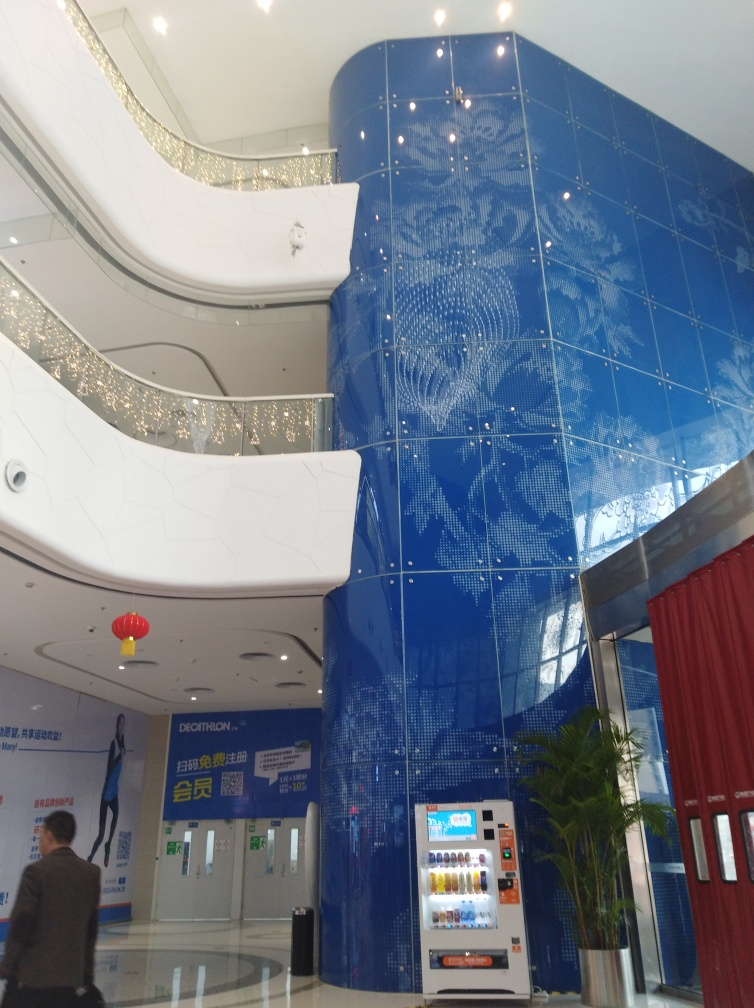What atmosphere does the interior design convey? The interior design exudes a sense of modern elegance and cutting-edge style. The combination of the dramatic blue mosaic wall, the sweeping white curves of the surrounding structure, and the sparkling lighting fixtures creates an upscale and inviting atmosphere that might be characteristic of a contemporary public space, commercial center, or an art gallery. 